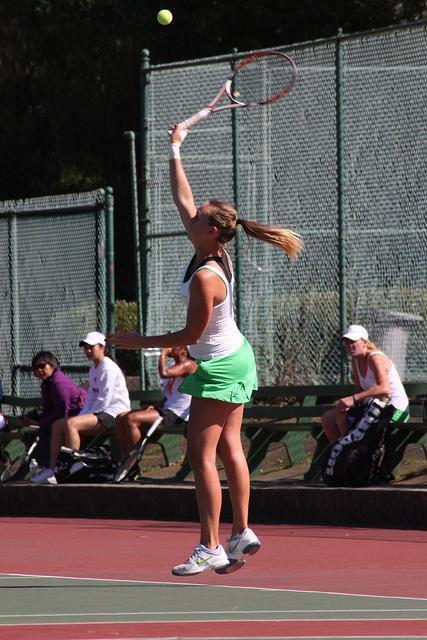How many chairs are there?
Give a very brief answer. 1. How many people are there?
Give a very brief answer. 5. How many clocks are on the counter?
Give a very brief answer. 0. 